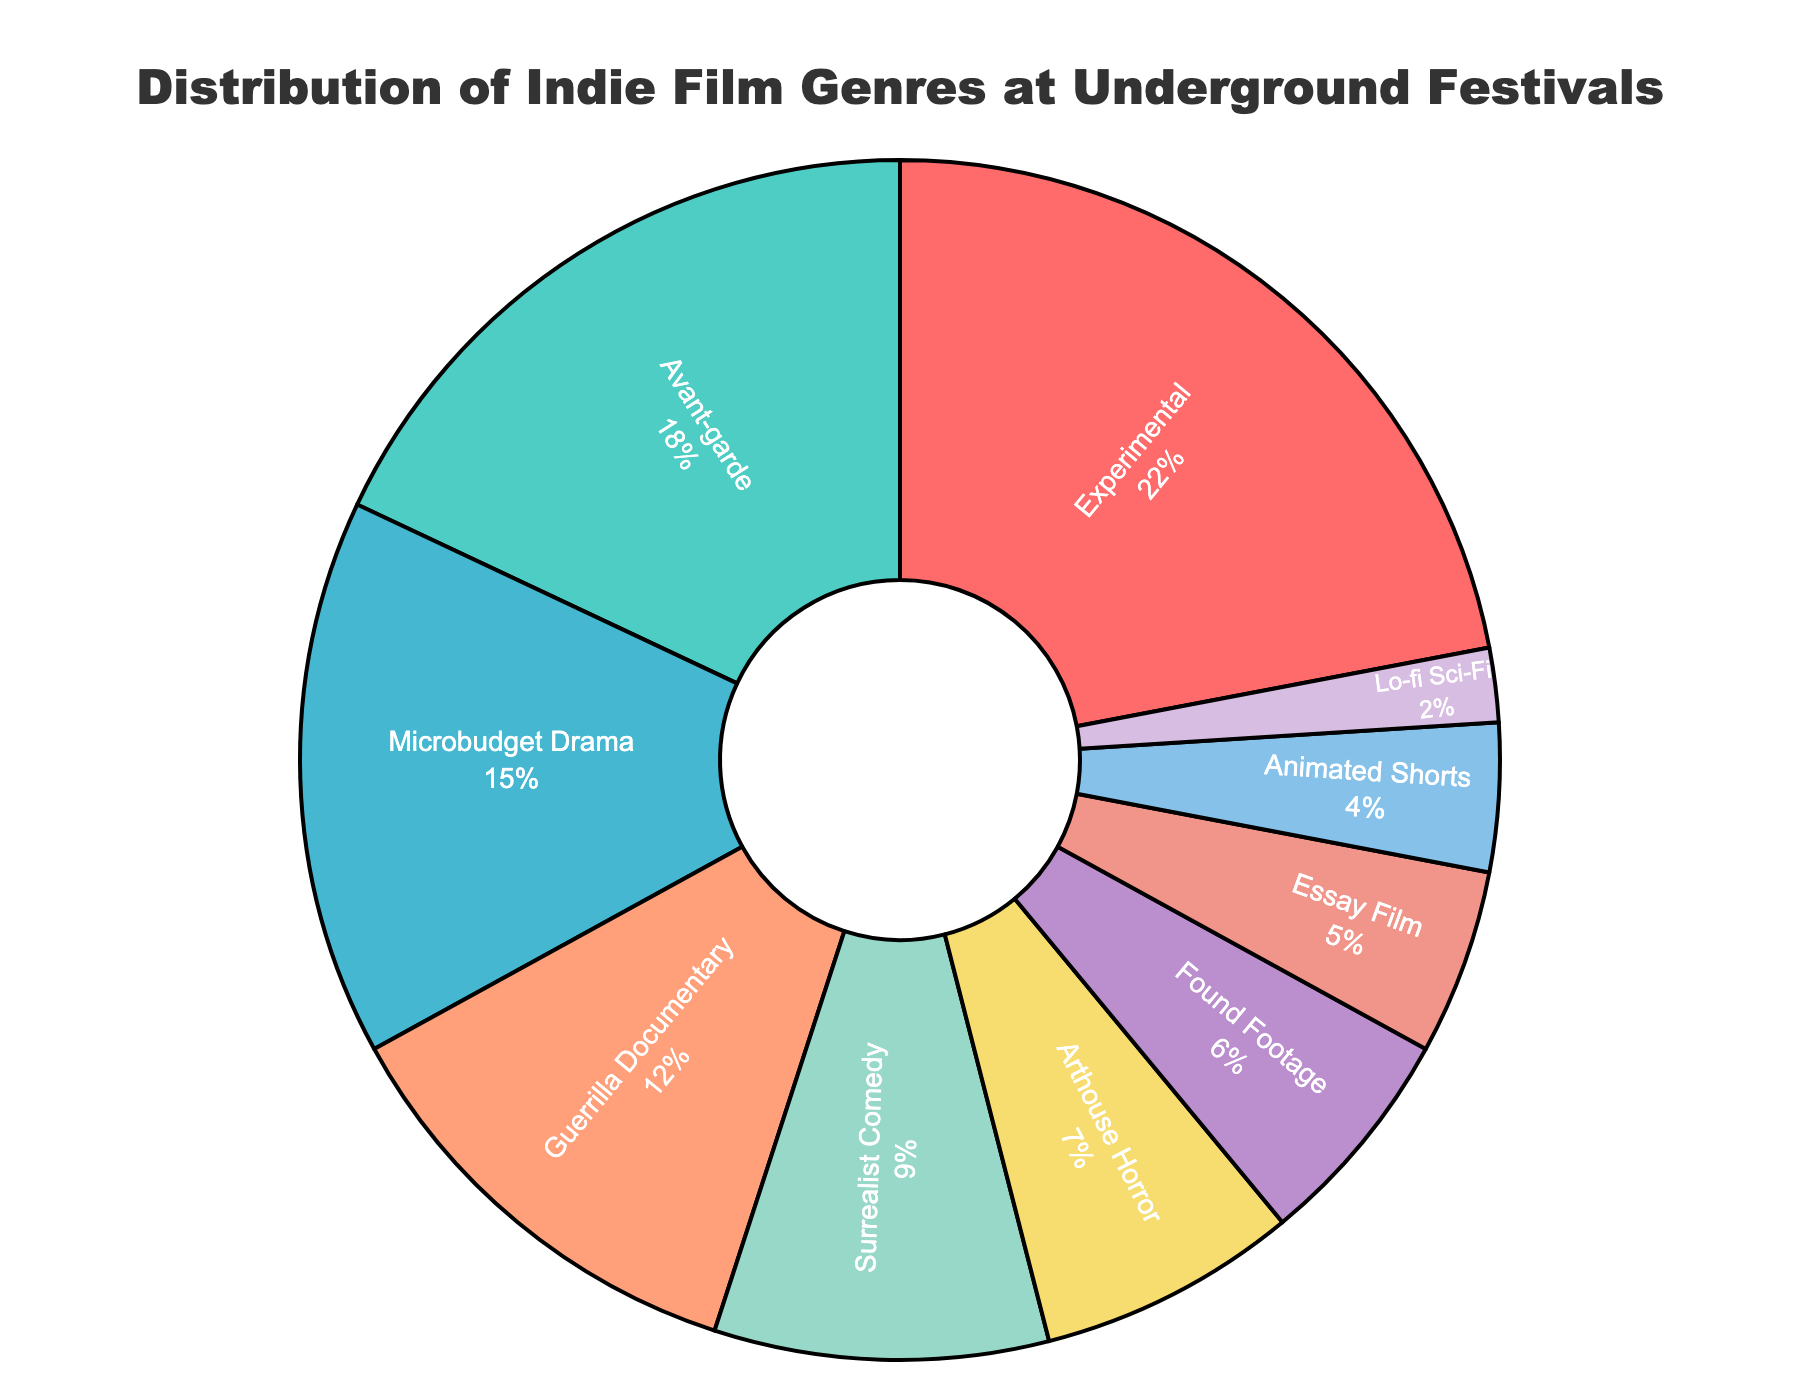what percentage of films are Experimental or Avant-garde? Add the percentages for Experimental (22%) and Avant-garde (18%): 22 + 18 = 40
Answer: 40 Which genre has a larger percentage, Microbudget Drama or Guerrilla Documentary? Compare the percentages of Microbudget Drama (15%) and Guerrilla Documentary (12%): 15 > 12
Answer: Microbudget Drama How many genres have a percentage greater than 10%? Count the genres with more than 10%: Experimental (22%), Avant-garde (18%), Microbudget Drama (15%), and Guerrilla Documentary (12%). Total: 4
Answer: 4 Which genre has the smallest percentage? Identify the genre with the smallest slice: Lo-fi Sci-Fi (2%)
Answer: Lo-fi Sci-Fi What is the combined percentage of Arthouse Horror, Found Footage, and Essay Film? Sum the percentages of Arthouse Horror (7%), Found Footage (6%), and Essay Film (5%): 7 + 6 + 5 = 18
Answer: 18 Is the percentage of Surrealist Comedy higher or lower than the combined percentage of Lo-fi Sci-Fi and Animated Shorts? Compare Surrealist Comedy (9%) with the combined percentage of Lo-fi Sci-Fi (2%) and Animated Shorts (4%): 9 > (2 + 4) = 6
Answer: Higher What is the difference in percentage between the most represented genre and the least represented genre? Subtract the percentage of Lo-fi Sci-Fi (2%) from Experimental (22%): 22 - 2 = 20
Answer: 20 How many genres have a smaller percentage than Surrealist Comedy? Count the genres with less than 9%: Arthouse Horror (7%), Found Footage (6%), Essay Film (5%), Animated Shorts (4%), Lo-fi Sci-Fi (2%). Total: 5
Answer: 5 